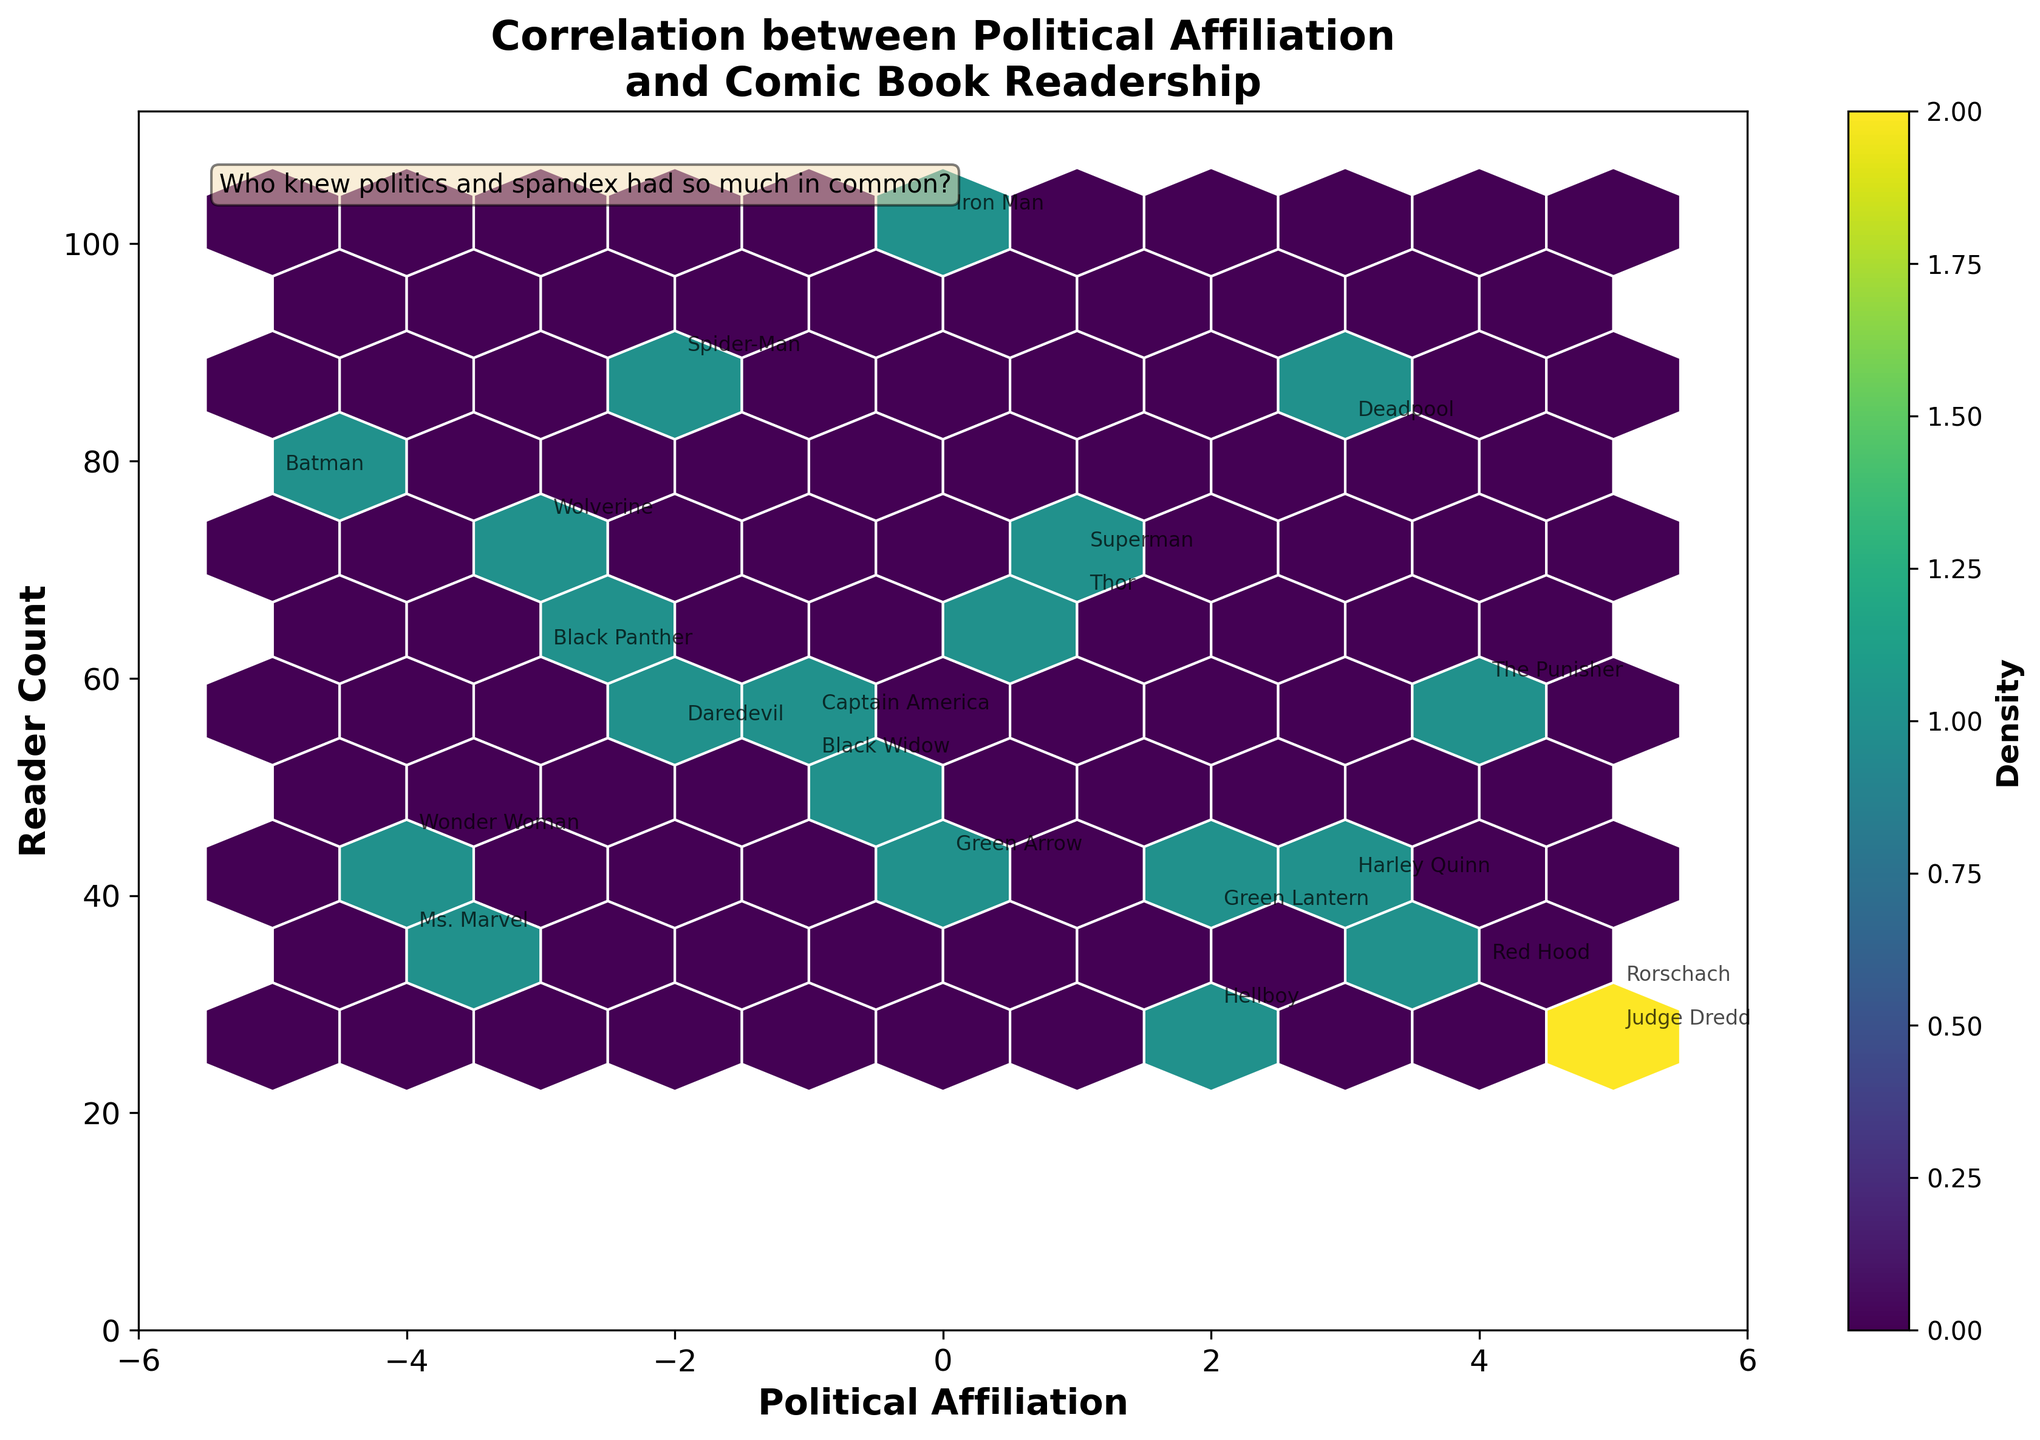What is the title of the plot? The title is located at the top of the plot and typically provides a brief description of what the plot represents. Here, the title is "Correlation between Political Affiliation and Comic Book Readership."
Answer: Correlation between Political Affiliation and Comic Book Readership What does the color represent in the hexbin plot? In hexbin plots, the color usually indicates the density of data points within each hexagon. This means that areas with darker or more intense colors have a higher concentration of data points. In this plot, the color ranging from lighter to darker shades represents the density of comic book readers with specific political affiliations and reader counts.
Answer: Density What's the label on the x-axis? The label on the x-axis indicates the variable plotted along the horizontal axis. Here, it is "Political Affiliation." This means that the x-axis shows different political affiliations of comic book readers ranging from -5 to 5.
Answer: Political Affiliation Which political affiliation has the highest density of readers? The highest density area can be identified by looking for the hexagon with the darkest or most intense color. In this plot, the highest density is observed around the area for a political affiliation of 0 to -1.
Answer: 0 to -1 How many superheroes are annotated on the plot? Superheroes are annotated on the plot as text labels at various points. By visually counting each unique superhero name annotated near the corresponding data points, we can determine the total number. There are annotations for 21 different superheroes.
Answer: 21 Which superhero is preferred by readers with a political affiliation of -3? To answer this, look at the points annotated for a political affiliation of -3. Two annotations can be seen: Black Panther and Wolverine.
Answer: Black Panther and Wolverine What is the range of reader counts displayed on the y-axis? The y-axis represents the reader count, and its range can be observed from the lowest to the highest value on the axis. The reader count ranges from 0 to around 110 based on the axis limits.
Answer: 0 to 110 How does the density change as political affiliation moves from -5 to 5? Observing the hexbin plot, notice how the density of data points (indicated by color) changes along the x-axis. The density seems to cluster around the center near 0 and becomes less dense as we move towards the extremes (both -5 and 5).
Answer: Decreases toward the extremes 